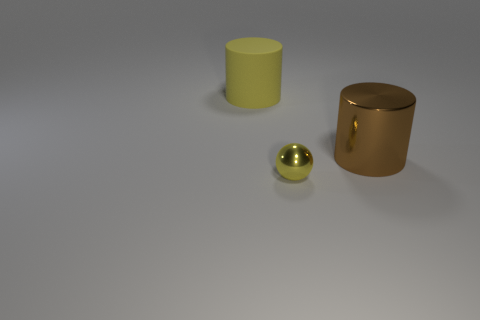Does the tiny yellow object have the same shape as the yellow thing behind the big brown metallic cylinder?
Provide a succinct answer. No. There is a thing that is both to the left of the big metal thing and in front of the yellow rubber object; what size is it?
Keep it short and to the point. Small. There is a thing that is to the right of the big yellow cylinder and behind the yellow metal thing; what is its color?
Keep it short and to the point. Brown. Is there anything else that is the same material as the small yellow thing?
Provide a short and direct response. Yes. Is the number of big brown objects that are behind the rubber thing less than the number of yellow cylinders that are in front of the big brown object?
Keep it short and to the point. No. Are there any other things of the same color as the metal sphere?
Provide a succinct answer. Yes. What shape is the matte thing?
Give a very brief answer. Cylinder. What is the color of the thing that is made of the same material as the small ball?
Provide a succinct answer. Brown. Is the number of tiny blue cubes greater than the number of brown metallic cylinders?
Give a very brief answer. No. Are any yellow things visible?
Provide a succinct answer. Yes. 